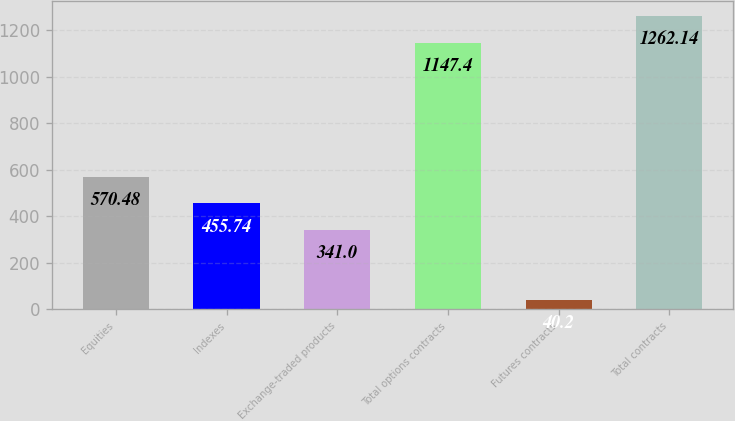<chart> <loc_0><loc_0><loc_500><loc_500><bar_chart><fcel>Equities<fcel>Indexes<fcel>Exchange-traded products<fcel>Total options contracts<fcel>Futures contracts<fcel>Total contracts<nl><fcel>570.48<fcel>455.74<fcel>341<fcel>1147.4<fcel>40.2<fcel>1262.14<nl></chart> 